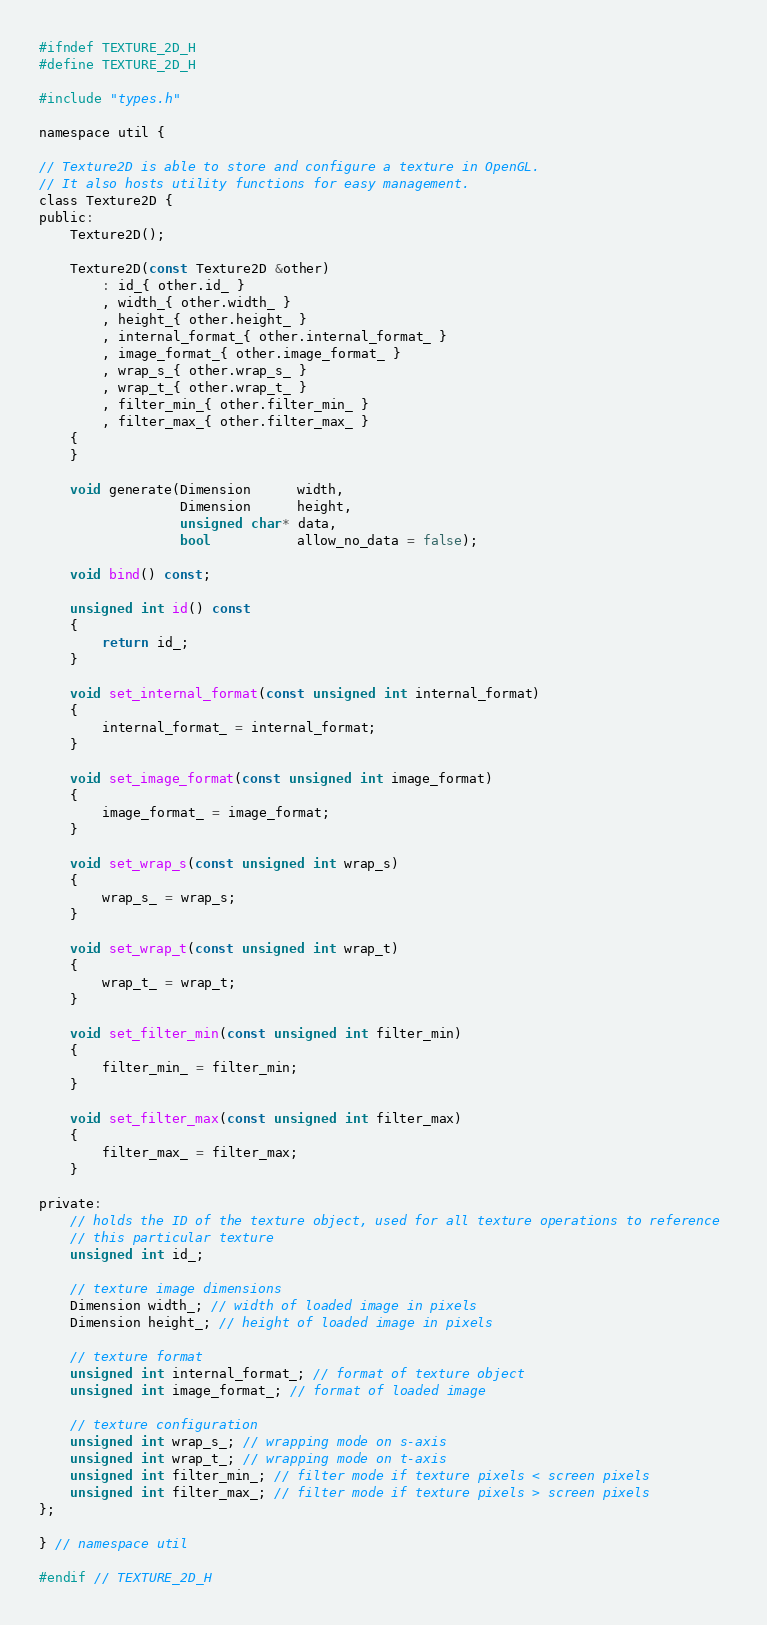<code> <loc_0><loc_0><loc_500><loc_500><_C_>#ifndef TEXTURE_2D_H
#define TEXTURE_2D_H

#include "types.h"

namespace util {

// Texture2D is able to store and configure a texture in OpenGL.
// It also hosts utility functions for easy management.
class Texture2D {
public:
	Texture2D();

	Texture2D(const Texture2D &other)
		: id_{ other.id_ }
		, width_{ other.width_ }
		, height_{ other.height_ }
		, internal_format_{ other.internal_format_ }
		, image_format_{ other.image_format_ }
		, wrap_s_{ other.wrap_s_ }
		, wrap_t_{ other.wrap_t_ }
		, filter_min_{ other.filter_min_ }
		, filter_max_{ other.filter_max_ }
	{
	}

	void generate(Dimension      width, 
				  Dimension      height, 
				  unsigned char* data,
				  bool           allow_no_data = false);

	void bind() const;

	unsigned int id() const
	{
		return id_;
	}

	void set_internal_format(const unsigned int internal_format)
	{
		internal_format_ = internal_format;
	}

	void set_image_format(const unsigned int image_format)
	{
		image_format_ = image_format;
	}

	void set_wrap_s(const unsigned int wrap_s)
	{
		wrap_s_ = wrap_s;
	}

	void set_wrap_t(const unsigned int wrap_t)
	{
		wrap_t_ = wrap_t;
	}

	void set_filter_min(const unsigned int filter_min)
	{
		filter_min_ = filter_min;
	}

	void set_filter_max(const unsigned int filter_max)
	{
		filter_max_ = filter_max;
	}

private:
	// holds the ID of the texture object, used for all texture operations to reference 
	// this particular texture
	unsigned int id_;

	// texture image dimensions
	Dimension width_; // width of loaded image in pixels
	Dimension height_; // height of loaded image in pixels

	// texture format
	unsigned int internal_format_; // format of texture object
	unsigned int image_format_; // format of loaded image

	// texture configuration
	unsigned int wrap_s_; // wrapping mode on s-axis
	unsigned int wrap_t_; // wrapping mode on t-axis
	unsigned int filter_min_; // filter mode if texture pixels < screen pixels
	unsigned int filter_max_; // filter mode if texture pixels > screen pixels
};

} // namespace util

#endif // TEXTURE_2D_H</code> 